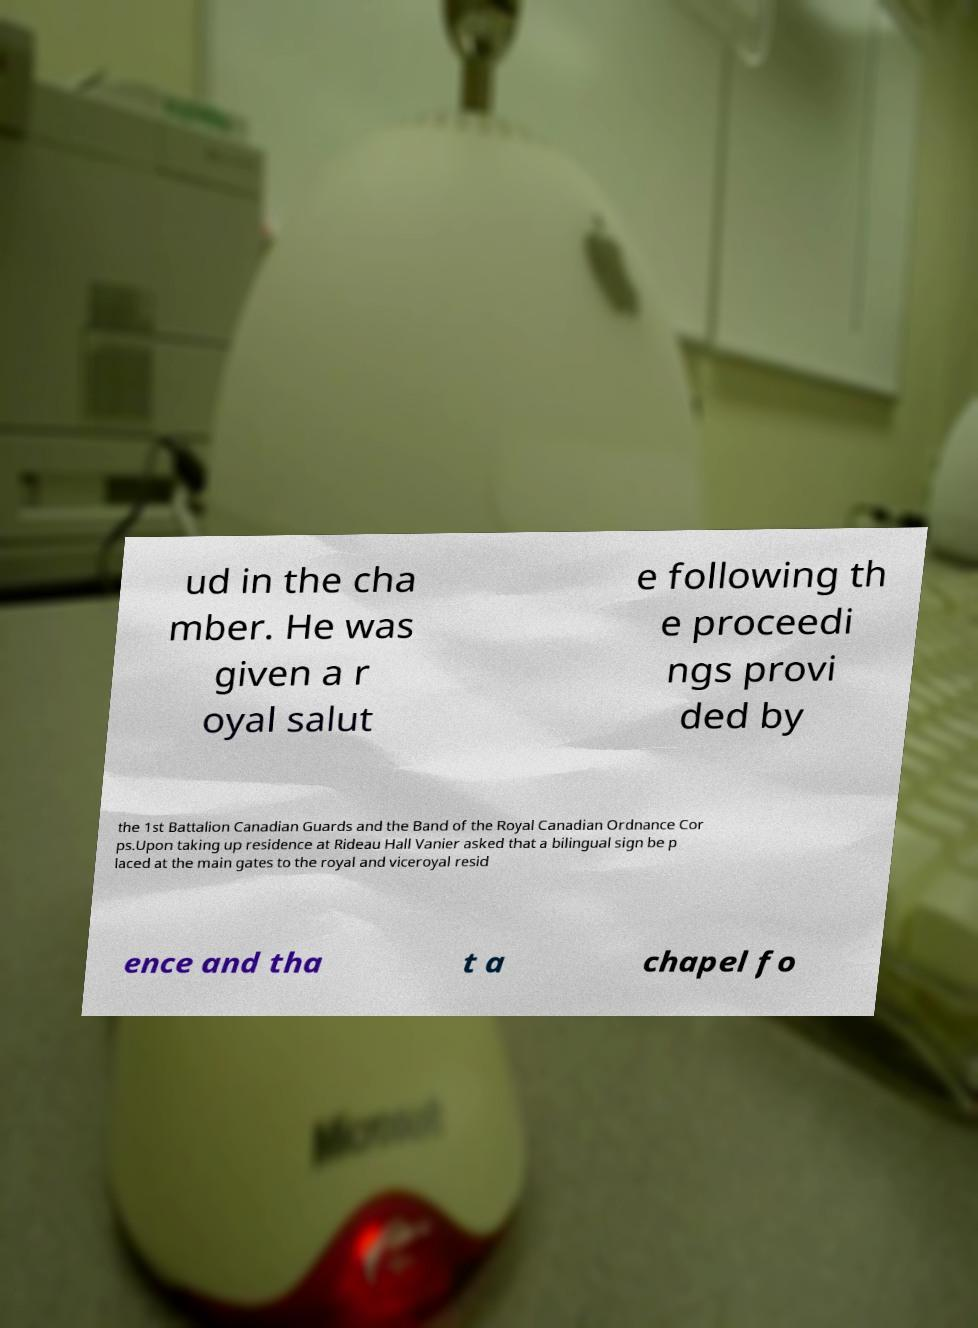Can you read and provide the text displayed in the image?This photo seems to have some interesting text. Can you extract and type it out for me? ud in the cha mber. He was given a r oyal salut e following th e proceedi ngs provi ded by the 1st Battalion Canadian Guards and the Band of the Royal Canadian Ordnance Cor ps.Upon taking up residence at Rideau Hall Vanier asked that a bilingual sign be p laced at the main gates to the royal and viceroyal resid ence and tha t a chapel fo 